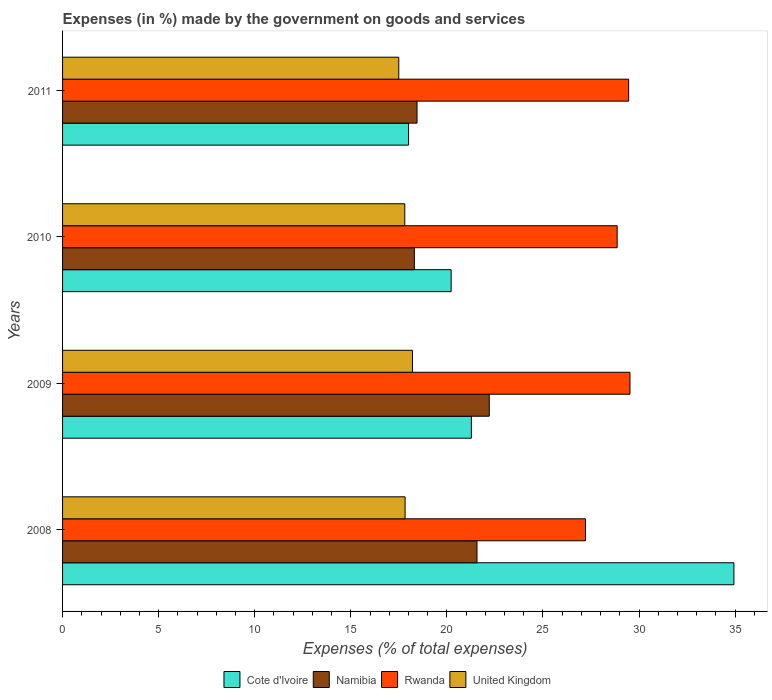Are the number of bars on each tick of the Y-axis equal?
Ensure brevity in your answer.  Yes. How many bars are there on the 4th tick from the top?
Give a very brief answer. 4. How many bars are there on the 1st tick from the bottom?
Ensure brevity in your answer.  4. What is the label of the 3rd group of bars from the top?
Your answer should be compact. 2009. What is the percentage of expenses made by the government on goods and services in Namibia in 2009?
Make the answer very short. 22.21. Across all years, what is the maximum percentage of expenses made by the government on goods and services in United Kingdom?
Offer a very short reply. 18.21. Across all years, what is the minimum percentage of expenses made by the government on goods and services in United Kingdom?
Provide a succinct answer. 17.5. What is the total percentage of expenses made by the government on goods and services in Cote d'Ivoire in the graph?
Offer a very short reply. 94.44. What is the difference between the percentage of expenses made by the government on goods and services in Namibia in 2008 and that in 2010?
Your answer should be very brief. 3.26. What is the difference between the percentage of expenses made by the government on goods and services in Namibia in 2010 and the percentage of expenses made by the government on goods and services in Cote d'Ivoire in 2008?
Offer a very short reply. -16.63. What is the average percentage of expenses made by the government on goods and services in Cote d'Ivoire per year?
Give a very brief answer. 23.61. In the year 2009, what is the difference between the percentage of expenses made by the government on goods and services in Cote d'Ivoire and percentage of expenses made by the government on goods and services in Rwanda?
Offer a terse response. -8.25. What is the ratio of the percentage of expenses made by the government on goods and services in Namibia in 2009 to that in 2011?
Your answer should be very brief. 1.2. Is the difference between the percentage of expenses made by the government on goods and services in Cote d'Ivoire in 2009 and 2011 greater than the difference between the percentage of expenses made by the government on goods and services in Rwanda in 2009 and 2011?
Ensure brevity in your answer.  Yes. What is the difference between the highest and the second highest percentage of expenses made by the government on goods and services in Rwanda?
Provide a succinct answer. 0.07. What is the difference between the highest and the lowest percentage of expenses made by the government on goods and services in Namibia?
Offer a terse response. 3.9. In how many years, is the percentage of expenses made by the government on goods and services in Namibia greater than the average percentage of expenses made by the government on goods and services in Namibia taken over all years?
Your answer should be very brief. 2. Is it the case that in every year, the sum of the percentage of expenses made by the government on goods and services in United Kingdom and percentage of expenses made by the government on goods and services in Rwanda is greater than the sum of percentage of expenses made by the government on goods and services in Cote d'Ivoire and percentage of expenses made by the government on goods and services in Namibia?
Give a very brief answer. No. What does the 1st bar from the top in 2009 represents?
Your answer should be compact. United Kingdom. What does the 3rd bar from the bottom in 2008 represents?
Offer a very short reply. Rwanda. How many bars are there?
Ensure brevity in your answer.  16. Does the graph contain any zero values?
Give a very brief answer. No. Where does the legend appear in the graph?
Ensure brevity in your answer.  Bottom center. How many legend labels are there?
Make the answer very short. 4. How are the legend labels stacked?
Keep it short and to the point. Horizontal. What is the title of the graph?
Make the answer very short. Expenses (in %) made by the government on goods and services. Does "Other small states" appear as one of the legend labels in the graph?
Give a very brief answer. No. What is the label or title of the X-axis?
Offer a terse response. Expenses (% of total expenses). What is the label or title of the Y-axis?
Give a very brief answer. Years. What is the Expenses (% of total expenses) in Cote d'Ivoire in 2008?
Offer a very short reply. 34.94. What is the Expenses (% of total expenses) in Namibia in 2008?
Make the answer very short. 21.57. What is the Expenses (% of total expenses) of Rwanda in 2008?
Give a very brief answer. 27.21. What is the Expenses (% of total expenses) of United Kingdom in 2008?
Your answer should be compact. 17.83. What is the Expenses (% of total expenses) of Cote d'Ivoire in 2009?
Ensure brevity in your answer.  21.27. What is the Expenses (% of total expenses) in Namibia in 2009?
Your answer should be very brief. 22.21. What is the Expenses (% of total expenses) of Rwanda in 2009?
Your answer should be compact. 29.53. What is the Expenses (% of total expenses) in United Kingdom in 2009?
Offer a very short reply. 18.21. What is the Expenses (% of total expenses) in Cote d'Ivoire in 2010?
Ensure brevity in your answer.  20.22. What is the Expenses (% of total expenses) in Namibia in 2010?
Keep it short and to the point. 18.31. What is the Expenses (% of total expenses) of Rwanda in 2010?
Ensure brevity in your answer.  28.86. What is the Expenses (% of total expenses) in United Kingdom in 2010?
Your answer should be compact. 17.81. What is the Expenses (% of total expenses) of Cote d'Ivoire in 2011?
Offer a very short reply. 18.01. What is the Expenses (% of total expenses) of Namibia in 2011?
Ensure brevity in your answer.  18.45. What is the Expenses (% of total expenses) of Rwanda in 2011?
Your response must be concise. 29.46. What is the Expenses (% of total expenses) in United Kingdom in 2011?
Your response must be concise. 17.5. Across all years, what is the maximum Expenses (% of total expenses) in Cote d'Ivoire?
Your response must be concise. 34.94. Across all years, what is the maximum Expenses (% of total expenses) in Namibia?
Your response must be concise. 22.21. Across all years, what is the maximum Expenses (% of total expenses) in Rwanda?
Offer a very short reply. 29.53. Across all years, what is the maximum Expenses (% of total expenses) of United Kingdom?
Your answer should be very brief. 18.21. Across all years, what is the minimum Expenses (% of total expenses) of Cote d'Ivoire?
Offer a very short reply. 18.01. Across all years, what is the minimum Expenses (% of total expenses) in Namibia?
Your answer should be compact. 18.31. Across all years, what is the minimum Expenses (% of total expenses) in Rwanda?
Give a very brief answer. 27.21. Across all years, what is the minimum Expenses (% of total expenses) in United Kingdom?
Your answer should be very brief. 17.5. What is the total Expenses (% of total expenses) of Cote d'Ivoire in the graph?
Provide a short and direct response. 94.44. What is the total Expenses (% of total expenses) in Namibia in the graph?
Make the answer very short. 80.53. What is the total Expenses (% of total expenses) in Rwanda in the graph?
Give a very brief answer. 115.06. What is the total Expenses (% of total expenses) in United Kingdom in the graph?
Make the answer very short. 71.34. What is the difference between the Expenses (% of total expenses) in Cote d'Ivoire in 2008 and that in 2009?
Ensure brevity in your answer.  13.66. What is the difference between the Expenses (% of total expenses) of Namibia in 2008 and that in 2009?
Offer a terse response. -0.64. What is the difference between the Expenses (% of total expenses) in Rwanda in 2008 and that in 2009?
Offer a terse response. -2.32. What is the difference between the Expenses (% of total expenses) of United Kingdom in 2008 and that in 2009?
Provide a short and direct response. -0.38. What is the difference between the Expenses (% of total expenses) in Cote d'Ivoire in 2008 and that in 2010?
Your answer should be compact. 14.72. What is the difference between the Expenses (% of total expenses) in Namibia in 2008 and that in 2010?
Your answer should be very brief. 3.26. What is the difference between the Expenses (% of total expenses) of Rwanda in 2008 and that in 2010?
Ensure brevity in your answer.  -1.65. What is the difference between the Expenses (% of total expenses) of United Kingdom in 2008 and that in 2010?
Keep it short and to the point. 0.02. What is the difference between the Expenses (% of total expenses) in Cote d'Ivoire in 2008 and that in 2011?
Your answer should be very brief. 16.93. What is the difference between the Expenses (% of total expenses) in Namibia in 2008 and that in 2011?
Your answer should be very brief. 3.12. What is the difference between the Expenses (% of total expenses) in Rwanda in 2008 and that in 2011?
Your response must be concise. -2.25. What is the difference between the Expenses (% of total expenses) in United Kingdom in 2008 and that in 2011?
Keep it short and to the point. 0.33. What is the difference between the Expenses (% of total expenses) in Cote d'Ivoire in 2009 and that in 2010?
Your response must be concise. 1.05. What is the difference between the Expenses (% of total expenses) of Namibia in 2009 and that in 2010?
Your answer should be very brief. 3.9. What is the difference between the Expenses (% of total expenses) in Rwanda in 2009 and that in 2010?
Your answer should be very brief. 0.67. What is the difference between the Expenses (% of total expenses) of United Kingdom in 2009 and that in 2010?
Provide a short and direct response. 0.4. What is the difference between the Expenses (% of total expenses) of Cote d'Ivoire in 2009 and that in 2011?
Make the answer very short. 3.27. What is the difference between the Expenses (% of total expenses) of Namibia in 2009 and that in 2011?
Keep it short and to the point. 3.76. What is the difference between the Expenses (% of total expenses) of Rwanda in 2009 and that in 2011?
Your response must be concise. 0.07. What is the difference between the Expenses (% of total expenses) of United Kingdom in 2009 and that in 2011?
Provide a short and direct response. 0.71. What is the difference between the Expenses (% of total expenses) in Cote d'Ivoire in 2010 and that in 2011?
Make the answer very short. 2.22. What is the difference between the Expenses (% of total expenses) of Namibia in 2010 and that in 2011?
Your answer should be very brief. -0.14. What is the difference between the Expenses (% of total expenses) of Rwanda in 2010 and that in 2011?
Give a very brief answer. -0.6. What is the difference between the Expenses (% of total expenses) in United Kingdom in 2010 and that in 2011?
Provide a succinct answer. 0.31. What is the difference between the Expenses (% of total expenses) in Cote d'Ivoire in 2008 and the Expenses (% of total expenses) in Namibia in 2009?
Keep it short and to the point. 12.73. What is the difference between the Expenses (% of total expenses) of Cote d'Ivoire in 2008 and the Expenses (% of total expenses) of Rwanda in 2009?
Offer a very short reply. 5.41. What is the difference between the Expenses (% of total expenses) of Cote d'Ivoire in 2008 and the Expenses (% of total expenses) of United Kingdom in 2009?
Keep it short and to the point. 16.73. What is the difference between the Expenses (% of total expenses) in Namibia in 2008 and the Expenses (% of total expenses) in Rwanda in 2009?
Give a very brief answer. -7.96. What is the difference between the Expenses (% of total expenses) of Namibia in 2008 and the Expenses (% of total expenses) of United Kingdom in 2009?
Your answer should be compact. 3.36. What is the difference between the Expenses (% of total expenses) in Rwanda in 2008 and the Expenses (% of total expenses) in United Kingdom in 2009?
Give a very brief answer. 9. What is the difference between the Expenses (% of total expenses) of Cote d'Ivoire in 2008 and the Expenses (% of total expenses) of Namibia in 2010?
Your response must be concise. 16.63. What is the difference between the Expenses (% of total expenses) in Cote d'Ivoire in 2008 and the Expenses (% of total expenses) in Rwanda in 2010?
Provide a short and direct response. 6.08. What is the difference between the Expenses (% of total expenses) in Cote d'Ivoire in 2008 and the Expenses (% of total expenses) in United Kingdom in 2010?
Your answer should be very brief. 17.13. What is the difference between the Expenses (% of total expenses) in Namibia in 2008 and the Expenses (% of total expenses) in Rwanda in 2010?
Your answer should be very brief. -7.29. What is the difference between the Expenses (% of total expenses) of Namibia in 2008 and the Expenses (% of total expenses) of United Kingdom in 2010?
Offer a very short reply. 3.76. What is the difference between the Expenses (% of total expenses) of Rwanda in 2008 and the Expenses (% of total expenses) of United Kingdom in 2010?
Offer a terse response. 9.4. What is the difference between the Expenses (% of total expenses) of Cote d'Ivoire in 2008 and the Expenses (% of total expenses) of Namibia in 2011?
Your response must be concise. 16.49. What is the difference between the Expenses (% of total expenses) of Cote d'Ivoire in 2008 and the Expenses (% of total expenses) of Rwanda in 2011?
Keep it short and to the point. 5.48. What is the difference between the Expenses (% of total expenses) of Cote d'Ivoire in 2008 and the Expenses (% of total expenses) of United Kingdom in 2011?
Provide a short and direct response. 17.44. What is the difference between the Expenses (% of total expenses) in Namibia in 2008 and the Expenses (% of total expenses) in Rwanda in 2011?
Your response must be concise. -7.89. What is the difference between the Expenses (% of total expenses) of Namibia in 2008 and the Expenses (% of total expenses) of United Kingdom in 2011?
Give a very brief answer. 4.07. What is the difference between the Expenses (% of total expenses) in Rwanda in 2008 and the Expenses (% of total expenses) in United Kingdom in 2011?
Your response must be concise. 9.72. What is the difference between the Expenses (% of total expenses) of Cote d'Ivoire in 2009 and the Expenses (% of total expenses) of Namibia in 2010?
Your response must be concise. 2.97. What is the difference between the Expenses (% of total expenses) of Cote d'Ivoire in 2009 and the Expenses (% of total expenses) of Rwanda in 2010?
Your answer should be compact. -7.59. What is the difference between the Expenses (% of total expenses) of Cote d'Ivoire in 2009 and the Expenses (% of total expenses) of United Kingdom in 2010?
Provide a succinct answer. 3.47. What is the difference between the Expenses (% of total expenses) of Namibia in 2009 and the Expenses (% of total expenses) of Rwanda in 2010?
Keep it short and to the point. -6.66. What is the difference between the Expenses (% of total expenses) in Namibia in 2009 and the Expenses (% of total expenses) in United Kingdom in 2010?
Your response must be concise. 4.4. What is the difference between the Expenses (% of total expenses) of Rwanda in 2009 and the Expenses (% of total expenses) of United Kingdom in 2010?
Your answer should be compact. 11.72. What is the difference between the Expenses (% of total expenses) of Cote d'Ivoire in 2009 and the Expenses (% of total expenses) of Namibia in 2011?
Offer a terse response. 2.83. What is the difference between the Expenses (% of total expenses) in Cote d'Ivoire in 2009 and the Expenses (% of total expenses) in Rwanda in 2011?
Your answer should be compact. -8.19. What is the difference between the Expenses (% of total expenses) in Cote d'Ivoire in 2009 and the Expenses (% of total expenses) in United Kingdom in 2011?
Provide a succinct answer. 3.78. What is the difference between the Expenses (% of total expenses) in Namibia in 2009 and the Expenses (% of total expenses) in Rwanda in 2011?
Ensure brevity in your answer.  -7.25. What is the difference between the Expenses (% of total expenses) of Namibia in 2009 and the Expenses (% of total expenses) of United Kingdom in 2011?
Keep it short and to the point. 4.71. What is the difference between the Expenses (% of total expenses) in Rwanda in 2009 and the Expenses (% of total expenses) in United Kingdom in 2011?
Ensure brevity in your answer.  12.03. What is the difference between the Expenses (% of total expenses) of Cote d'Ivoire in 2010 and the Expenses (% of total expenses) of Namibia in 2011?
Your answer should be very brief. 1.78. What is the difference between the Expenses (% of total expenses) in Cote d'Ivoire in 2010 and the Expenses (% of total expenses) in Rwanda in 2011?
Your answer should be very brief. -9.24. What is the difference between the Expenses (% of total expenses) of Cote d'Ivoire in 2010 and the Expenses (% of total expenses) of United Kingdom in 2011?
Your answer should be compact. 2.73. What is the difference between the Expenses (% of total expenses) of Namibia in 2010 and the Expenses (% of total expenses) of Rwanda in 2011?
Your answer should be compact. -11.15. What is the difference between the Expenses (% of total expenses) of Namibia in 2010 and the Expenses (% of total expenses) of United Kingdom in 2011?
Your answer should be very brief. 0.81. What is the difference between the Expenses (% of total expenses) in Rwanda in 2010 and the Expenses (% of total expenses) in United Kingdom in 2011?
Provide a short and direct response. 11.36. What is the average Expenses (% of total expenses) of Cote d'Ivoire per year?
Keep it short and to the point. 23.61. What is the average Expenses (% of total expenses) in Namibia per year?
Offer a very short reply. 20.13. What is the average Expenses (% of total expenses) in Rwanda per year?
Keep it short and to the point. 28.77. What is the average Expenses (% of total expenses) of United Kingdom per year?
Make the answer very short. 17.84. In the year 2008, what is the difference between the Expenses (% of total expenses) of Cote d'Ivoire and Expenses (% of total expenses) of Namibia?
Your answer should be compact. 13.37. In the year 2008, what is the difference between the Expenses (% of total expenses) of Cote d'Ivoire and Expenses (% of total expenses) of Rwanda?
Provide a succinct answer. 7.73. In the year 2008, what is the difference between the Expenses (% of total expenses) of Cote d'Ivoire and Expenses (% of total expenses) of United Kingdom?
Your answer should be compact. 17.11. In the year 2008, what is the difference between the Expenses (% of total expenses) of Namibia and Expenses (% of total expenses) of Rwanda?
Ensure brevity in your answer.  -5.65. In the year 2008, what is the difference between the Expenses (% of total expenses) in Namibia and Expenses (% of total expenses) in United Kingdom?
Make the answer very short. 3.74. In the year 2008, what is the difference between the Expenses (% of total expenses) of Rwanda and Expenses (% of total expenses) of United Kingdom?
Your answer should be compact. 9.39. In the year 2009, what is the difference between the Expenses (% of total expenses) of Cote d'Ivoire and Expenses (% of total expenses) of Namibia?
Offer a terse response. -0.93. In the year 2009, what is the difference between the Expenses (% of total expenses) of Cote d'Ivoire and Expenses (% of total expenses) of Rwanda?
Keep it short and to the point. -8.25. In the year 2009, what is the difference between the Expenses (% of total expenses) of Cote d'Ivoire and Expenses (% of total expenses) of United Kingdom?
Your answer should be compact. 3.07. In the year 2009, what is the difference between the Expenses (% of total expenses) in Namibia and Expenses (% of total expenses) in Rwanda?
Your answer should be compact. -7.32. In the year 2009, what is the difference between the Expenses (% of total expenses) in Namibia and Expenses (% of total expenses) in United Kingdom?
Your response must be concise. 4. In the year 2009, what is the difference between the Expenses (% of total expenses) of Rwanda and Expenses (% of total expenses) of United Kingdom?
Keep it short and to the point. 11.32. In the year 2010, what is the difference between the Expenses (% of total expenses) of Cote d'Ivoire and Expenses (% of total expenses) of Namibia?
Provide a short and direct response. 1.91. In the year 2010, what is the difference between the Expenses (% of total expenses) in Cote d'Ivoire and Expenses (% of total expenses) in Rwanda?
Make the answer very short. -8.64. In the year 2010, what is the difference between the Expenses (% of total expenses) of Cote d'Ivoire and Expenses (% of total expenses) of United Kingdom?
Offer a terse response. 2.41. In the year 2010, what is the difference between the Expenses (% of total expenses) in Namibia and Expenses (% of total expenses) in Rwanda?
Offer a very short reply. -10.55. In the year 2010, what is the difference between the Expenses (% of total expenses) in Namibia and Expenses (% of total expenses) in United Kingdom?
Ensure brevity in your answer.  0.5. In the year 2010, what is the difference between the Expenses (% of total expenses) in Rwanda and Expenses (% of total expenses) in United Kingdom?
Offer a very short reply. 11.05. In the year 2011, what is the difference between the Expenses (% of total expenses) of Cote d'Ivoire and Expenses (% of total expenses) of Namibia?
Make the answer very short. -0.44. In the year 2011, what is the difference between the Expenses (% of total expenses) in Cote d'Ivoire and Expenses (% of total expenses) in Rwanda?
Ensure brevity in your answer.  -11.45. In the year 2011, what is the difference between the Expenses (% of total expenses) of Cote d'Ivoire and Expenses (% of total expenses) of United Kingdom?
Keep it short and to the point. 0.51. In the year 2011, what is the difference between the Expenses (% of total expenses) of Namibia and Expenses (% of total expenses) of Rwanda?
Your answer should be compact. -11.01. In the year 2011, what is the difference between the Expenses (% of total expenses) in Namibia and Expenses (% of total expenses) in United Kingdom?
Your answer should be compact. 0.95. In the year 2011, what is the difference between the Expenses (% of total expenses) of Rwanda and Expenses (% of total expenses) of United Kingdom?
Your response must be concise. 11.96. What is the ratio of the Expenses (% of total expenses) of Cote d'Ivoire in 2008 to that in 2009?
Offer a terse response. 1.64. What is the ratio of the Expenses (% of total expenses) in Namibia in 2008 to that in 2009?
Your answer should be very brief. 0.97. What is the ratio of the Expenses (% of total expenses) of Rwanda in 2008 to that in 2009?
Make the answer very short. 0.92. What is the ratio of the Expenses (% of total expenses) in United Kingdom in 2008 to that in 2009?
Your answer should be very brief. 0.98. What is the ratio of the Expenses (% of total expenses) of Cote d'Ivoire in 2008 to that in 2010?
Give a very brief answer. 1.73. What is the ratio of the Expenses (% of total expenses) in Namibia in 2008 to that in 2010?
Provide a short and direct response. 1.18. What is the ratio of the Expenses (% of total expenses) in Rwanda in 2008 to that in 2010?
Provide a succinct answer. 0.94. What is the ratio of the Expenses (% of total expenses) of Cote d'Ivoire in 2008 to that in 2011?
Ensure brevity in your answer.  1.94. What is the ratio of the Expenses (% of total expenses) in Namibia in 2008 to that in 2011?
Your answer should be compact. 1.17. What is the ratio of the Expenses (% of total expenses) of Rwanda in 2008 to that in 2011?
Ensure brevity in your answer.  0.92. What is the ratio of the Expenses (% of total expenses) of United Kingdom in 2008 to that in 2011?
Offer a terse response. 1.02. What is the ratio of the Expenses (% of total expenses) of Cote d'Ivoire in 2009 to that in 2010?
Give a very brief answer. 1.05. What is the ratio of the Expenses (% of total expenses) of Namibia in 2009 to that in 2010?
Give a very brief answer. 1.21. What is the ratio of the Expenses (% of total expenses) in Rwanda in 2009 to that in 2010?
Provide a succinct answer. 1.02. What is the ratio of the Expenses (% of total expenses) of United Kingdom in 2009 to that in 2010?
Provide a short and direct response. 1.02. What is the ratio of the Expenses (% of total expenses) of Cote d'Ivoire in 2009 to that in 2011?
Provide a short and direct response. 1.18. What is the ratio of the Expenses (% of total expenses) in Namibia in 2009 to that in 2011?
Provide a short and direct response. 1.2. What is the ratio of the Expenses (% of total expenses) of Rwanda in 2009 to that in 2011?
Provide a short and direct response. 1. What is the ratio of the Expenses (% of total expenses) in United Kingdom in 2009 to that in 2011?
Your answer should be compact. 1.04. What is the ratio of the Expenses (% of total expenses) of Cote d'Ivoire in 2010 to that in 2011?
Your response must be concise. 1.12. What is the ratio of the Expenses (% of total expenses) in Rwanda in 2010 to that in 2011?
Your response must be concise. 0.98. What is the ratio of the Expenses (% of total expenses) of United Kingdom in 2010 to that in 2011?
Your answer should be very brief. 1.02. What is the difference between the highest and the second highest Expenses (% of total expenses) in Cote d'Ivoire?
Your answer should be very brief. 13.66. What is the difference between the highest and the second highest Expenses (% of total expenses) of Namibia?
Your answer should be very brief. 0.64. What is the difference between the highest and the second highest Expenses (% of total expenses) in Rwanda?
Ensure brevity in your answer.  0.07. What is the difference between the highest and the second highest Expenses (% of total expenses) in United Kingdom?
Keep it short and to the point. 0.38. What is the difference between the highest and the lowest Expenses (% of total expenses) in Cote d'Ivoire?
Offer a terse response. 16.93. What is the difference between the highest and the lowest Expenses (% of total expenses) of Namibia?
Ensure brevity in your answer.  3.9. What is the difference between the highest and the lowest Expenses (% of total expenses) of Rwanda?
Your response must be concise. 2.32. What is the difference between the highest and the lowest Expenses (% of total expenses) in United Kingdom?
Make the answer very short. 0.71. 